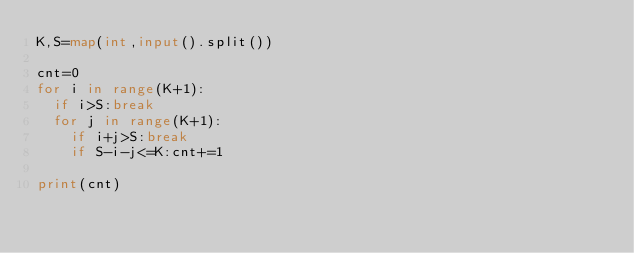Convert code to text. <code><loc_0><loc_0><loc_500><loc_500><_Python_>K,S=map(int,input().split())

cnt=0
for i in range(K+1):
	if i>S:break
	for j in range(K+1):
		if i+j>S:break
		if S-i-j<=K:cnt+=1

print(cnt)</code> 